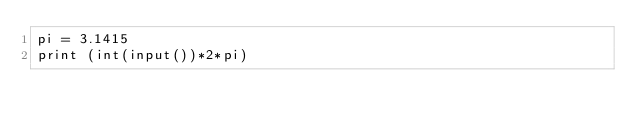Convert code to text. <code><loc_0><loc_0><loc_500><loc_500><_Python_>pi = 3.1415
print (int(input())*2*pi)</code> 